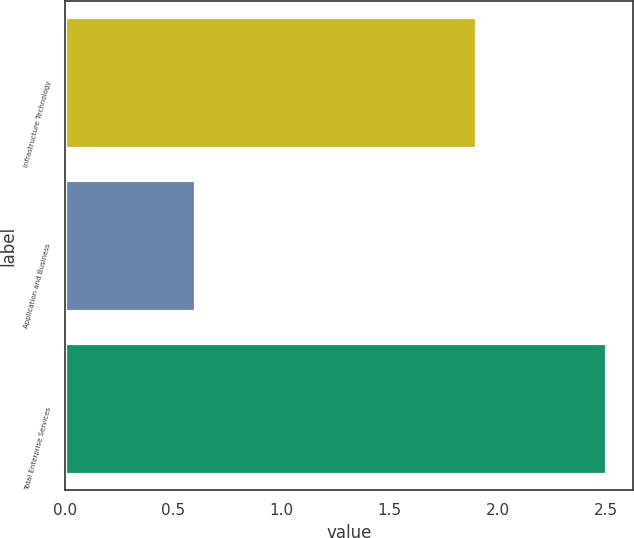Convert chart to OTSL. <chart><loc_0><loc_0><loc_500><loc_500><bar_chart><fcel>Infrastructure Technology<fcel>Application and Business<fcel>Total Enterprise Services<nl><fcel>1.9<fcel>0.6<fcel>2.5<nl></chart> 